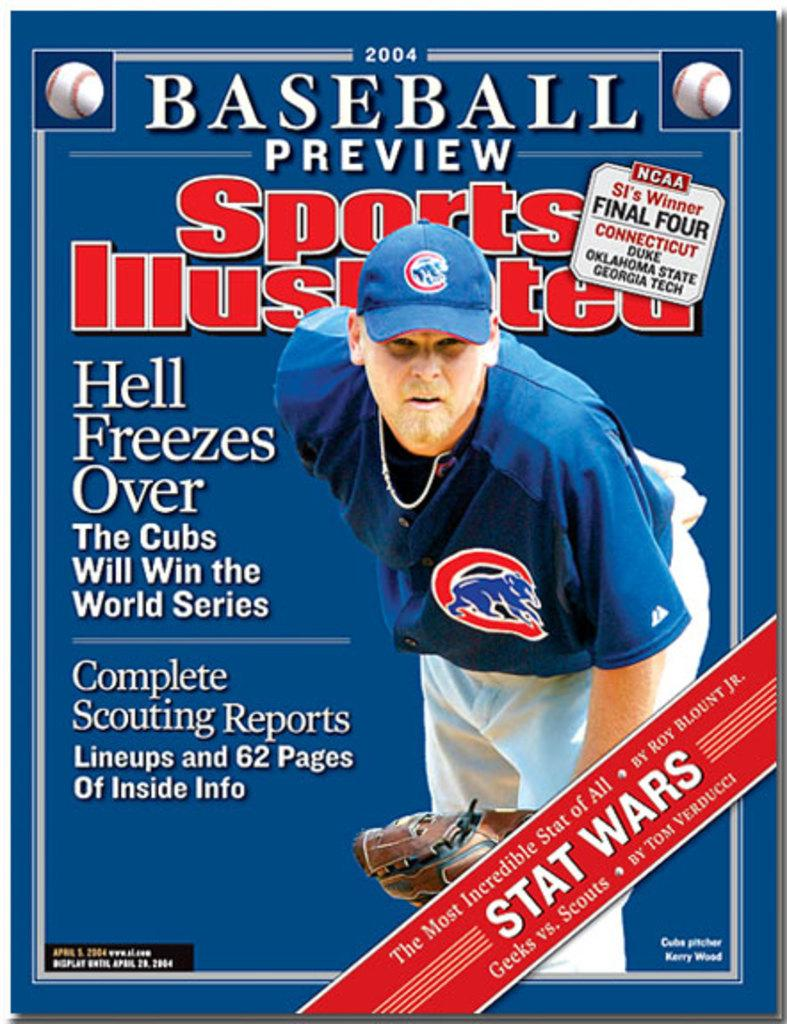<image>
Provide a brief description of the given image. The Sports Illustrated magazine features a Cub's baseball player. 